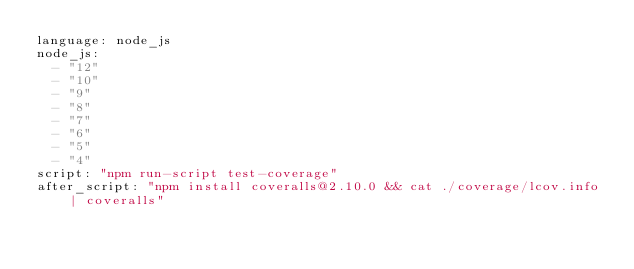<code> <loc_0><loc_0><loc_500><loc_500><_YAML_>language: node_js
node_js:
  - "12"
  - "10"
  - "9"
  - "8"
  - "7"
  - "6"
  - "5"
  - "4"
script: "npm run-script test-coverage"
after_script: "npm install coveralls@2.10.0 && cat ./coverage/lcov.info | coveralls"
</code> 